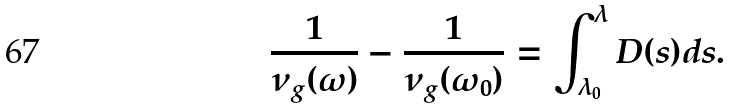Convert formula to latex. <formula><loc_0><loc_0><loc_500><loc_500>\frac { 1 } { \nu _ { g } ( \omega ) } - \frac { 1 } { \nu _ { g } ( \omega _ { 0 } ) } = \int _ { \lambda _ { 0 } } ^ { \lambda } D ( s ) d s .</formula> 